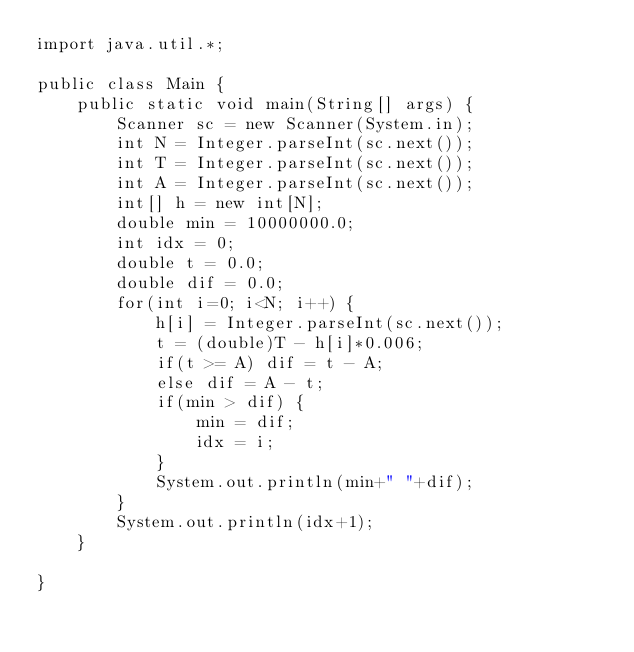<code> <loc_0><loc_0><loc_500><loc_500><_Java_>import java.util.*;
 
public class Main {
    public static void main(String[] args) {
        Scanner sc = new Scanner(System.in);
        int N = Integer.parseInt(sc.next());
        int T = Integer.parseInt(sc.next());
        int A = Integer.parseInt(sc.next());
        int[] h = new int[N];
        double min = 10000000.0;
        int idx = 0;
        double t = 0.0;
        double dif = 0.0;
        for(int i=0; i<N; i++) {
            h[i] = Integer.parseInt(sc.next());
            t = (double)T - h[i]*0.006;
            if(t >= A) dif = t - A;
            else dif = A - t;
            if(min > dif) {
                min = dif;
                idx = i;
            }
            System.out.println(min+" "+dif);
        }
        System.out.println(idx+1);
    }
    
}</code> 